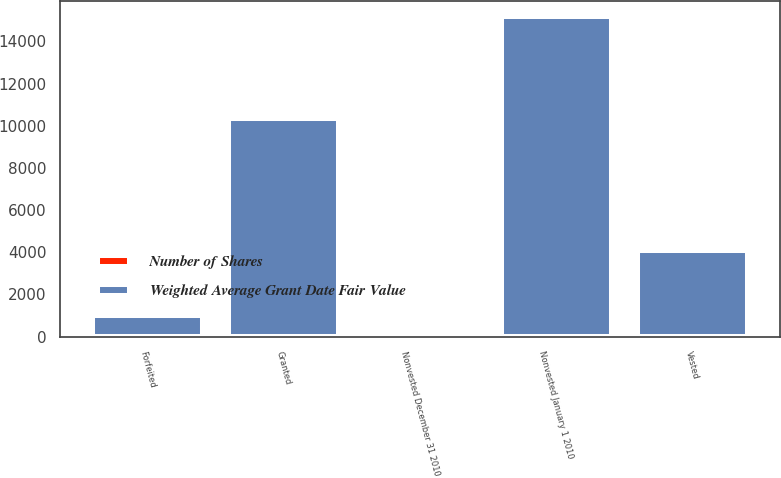<chart> <loc_0><loc_0><loc_500><loc_500><stacked_bar_chart><ecel><fcel>Nonvested January 1 2010<fcel>Granted<fcel>Vested<fcel>Forfeited<fcel>Nonvested December 31 2010<nl><fcel>Weighted Average Grant Date Fair Value<fcel>15119<fcel>10278<fcel>4029<fcel>930<fcel>36.4<nl><fcel>Number of Shares<fcel>33.06<fcel>33.98<fcel>36.4<fcel>32.68<fcel>32.88<nl></chart> 